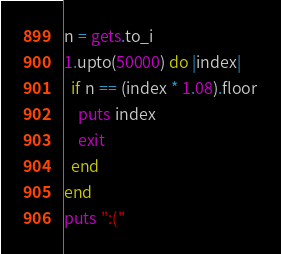<code> <loc_0><loc_0><loc_500><loc_500><_Ruby_>n = gets.to_i
1.upto(50000) do |index|
  if n == (index * 1.08).floor
    puts index
    exit
  end
end
puts ":("
</code> 